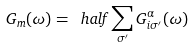<formula> <loc_0><loc_0><loc_500><loc_500>G _ { m } ( \omega ) = \ h a l f \sum _ { \sigma ^ { \prime } } G ^ { \alpha } _ { i \sigma ^ { \prime } } ( \omega )</formula> 